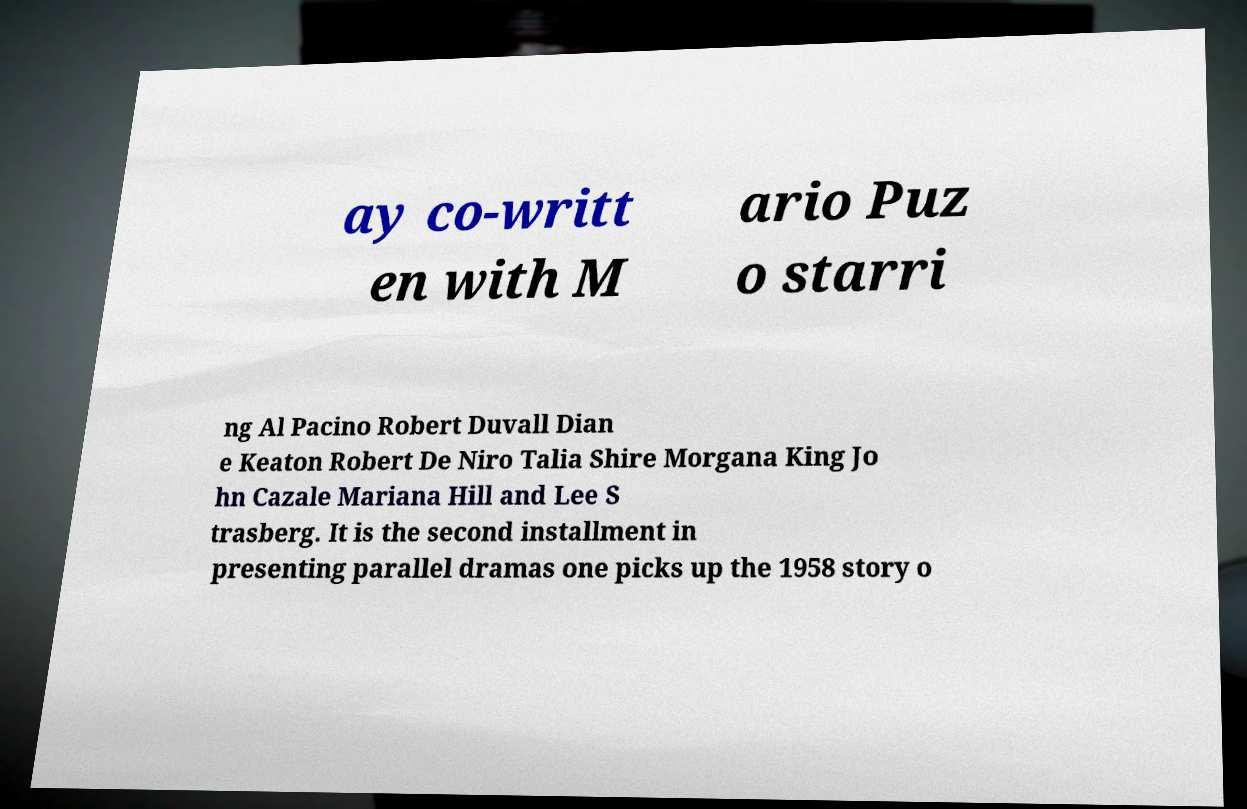Could you extract and type out the text from this image? ay co-writt en with M ario Puz o starri ng Al Pacino Robert Duvall Dian e Keaton Robert De Niro Talia Shire Morgana King Jo hn Cazale Mariana Hill and Lee S trasberg. It is the second installment in presenting parallel dramas one picks up the 1958 story o 